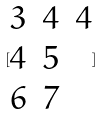<formula> <loc_0><loc_0><loc_500><loc_500>[ \begin{matrix} 3 & 4 & 4 \\ 4 & 5 \\ 6 & 7 \end{matrix} ]</formula> 